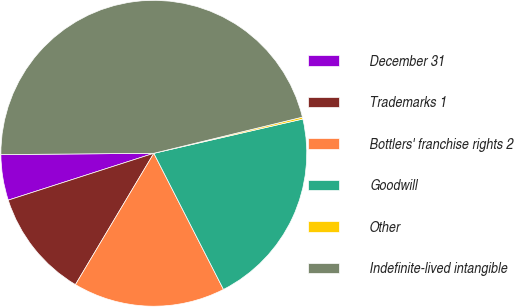<chart> <loc_0><loc_0><loc_500><loc_500><pie_chart><fcel>December 31<fcel>Trademarks 1<fcel>Bottlers' franchise rights 2<fcel>Goodwill<fcel>Other<fcel>Indefinite-lived intangible<nl><fcel>4.82%<fcel>11.48%<fcel>16.09%<fcel>21.07%<fcel>0.2%<fcel>46.33%<nl></chart> 